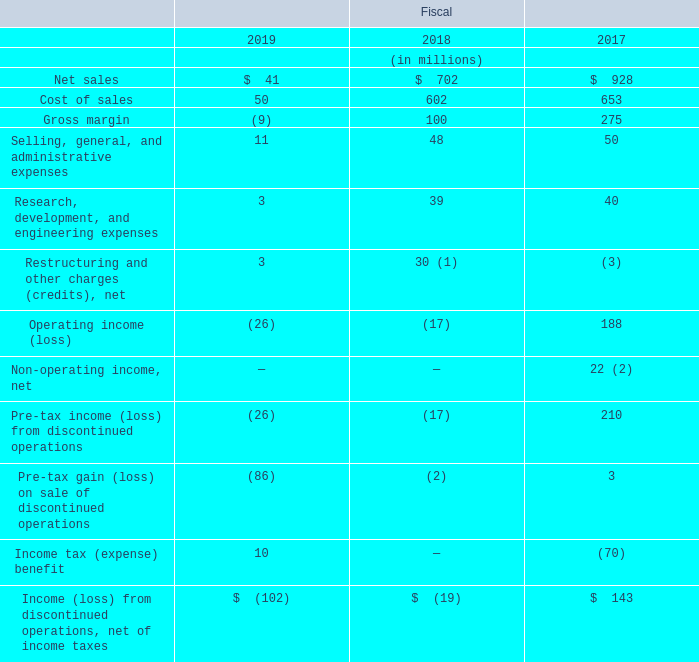4. Discontinued Operations
In fiscal 2019, we sold our Subsea Communications (“SubCom”) business for net cash proceeds of $297 million and incurred a pre-tax loss on sale of $86 million, related primarily to the recognition of cumulative translation adjustment losses of $67 million and the guarantee liabilities discussed below. The definitive agreement provided that, if the purchaser sells the business within two years of the closing date, we will be entitled to 20% of the net proceeds of that future sale, as defined in the agreement, in excess of $325 million. The sale of the SubCom business, which was previously included in our Communications Solutions segment, represents our exit from the telecommunications market and was significant to our sales and profitability, both to the Communications Solutions segment and to the consolidated company. We concluded that the divestiture was a strategic shift that had a major effect on our operations and financial results. As a result, the SubCom business met the held for sale and discontinued operations criteria and has been reported as such in all periods presented on our Consolidated Financial Statements.
Upon entering into the definitive agreement, which we consider a level 2 observable input in the fair value hierarchy, we assessed the carrying value of the SubCom business and determined that it was in excess of its fair value. In fiscal 2018, we recorded a pre-tax impairment charge of $19 million, which was included in income (loss) from discontinued operations on the Consolidated Statement of Operations, to write the carrying value of the business down to its estimated fair value less costs to sell.
In connection with the sale, we contractually agreed to continue to honor performance guarantees and letters of credit related to the SubCom business’ projects that existed as of the date of sale. These guarantees had a combined value of approximately $1.55 billion as of fiscal year end 2019 and are expected to expire at various dates through fiscal 2025; however, the majority are expected to expire by fiscal year end 2020. At the time of sale, we determined that the fair value of these guarantees was $12 million, which we recognized by a charge to pre-tax loss on sale. Also, under the terms of the definitive agreement, we are required to issue up to $300 million of new performance guarantees, subject to certain limitations, for projects entered into by the SubCom business following the sale for a period of up to three years. At fiscal year end 2019, there were no such new performance guarantees outstanding. We have contractual recourse against the SubCom business if we are required to perform on any SubCom guarantees; however, based on historical experience, we do not anticipate having to perform.
The following table presents the summarized components of income (loss) from discontinued operations, net of income taxes, for the SubCom business and prior divestitures:
(1) Included a $19 million impairment charge recorded in connection with the sale of our SubCom business.
(2) Included a $19 million credit related to the SubCom business’ curtailment of a postretirement benefit plan.
What did the amount of Restructuring and other charges (credits), net in 2018 include? $19 million impairment charge recorded in connection with the sale of our subcom business. What did the amount of Non-operating income, net in 2017 include? $19 million credit related to the subcom business’ curtailment of a postretirement benefit plan. For which years were the components of income (loss) from discontinued operations, net of income taxes, for the SubCom business and prior divestitures provided? 2019, 2018, 2017. In which year was the amount of Cost of sales largest? 653>602>50
Answer: 2017. What was the change in Selling, general, and administrative expenses in 2019 from 2018?
Answer scale should be: million. 11-48
Answer: -37. What was the percentage change in Selling, general, and administrative expenses in 2019 from 2018?
Answer scale should be: percent. (11-48)/48
Answer: -77.08. 